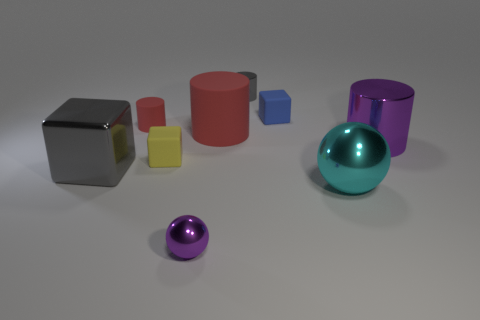Do the small blue object and the small yellow object have the same shape?
Your answer should be very brief. Yes. Are there any other things of the same color as the tiny rubber cylinder?
Give a very brief answer. Yes. There is a large metallic object that is the same color as the tiny ball; what shape is it?
Offer a terse response. Cylinder. What is the shape of the tiny thing behind the tiny blue block?
Provide a short and direct response. Cylinder. There is a purple metallic thing behind the big cyan thing right of the tiny yellow object; what is its shape?
Ensure brevity in your answer.  Cylinder. Is there another small matte thing of the same shape as the yellow matte thing?
Make the answer very short. Yes. The red rubber object that is the same size as the yellow rubber thing is what shape?
Ensure brevity in your answer.  Cylinder. There is a gray thing in front of the metallic thing that is behind the tiny red cylinder; are there any large cylinders that are behind it?
Offer a very short reply. Yes. Is there a blue rubber cube of the same size as the purple cylinder?
Keep it short and to the point. No. What size is the purple shiny thing to the right of the blue object?
Provide a succinct answer. Large. 